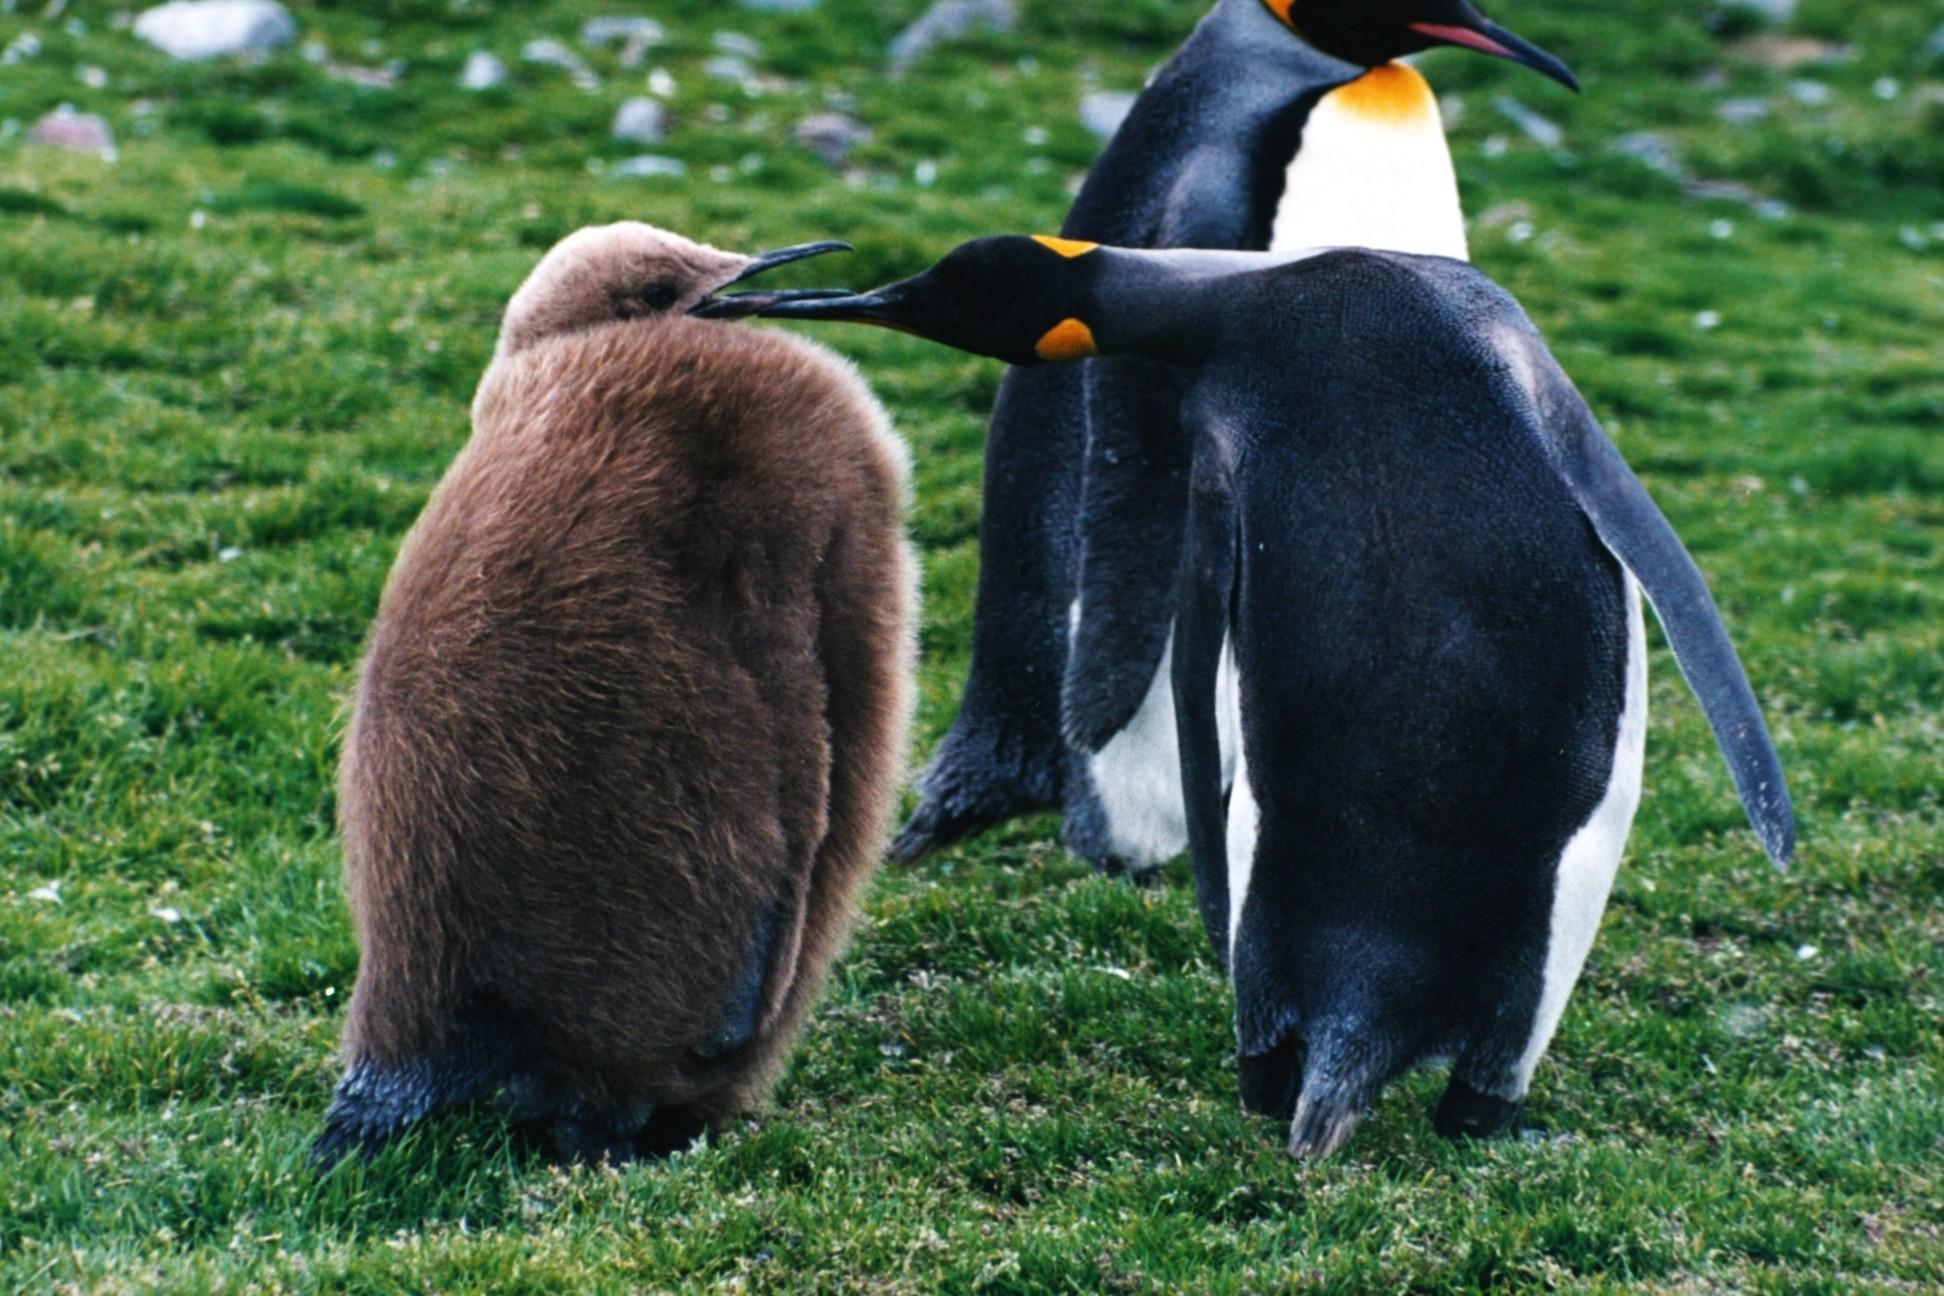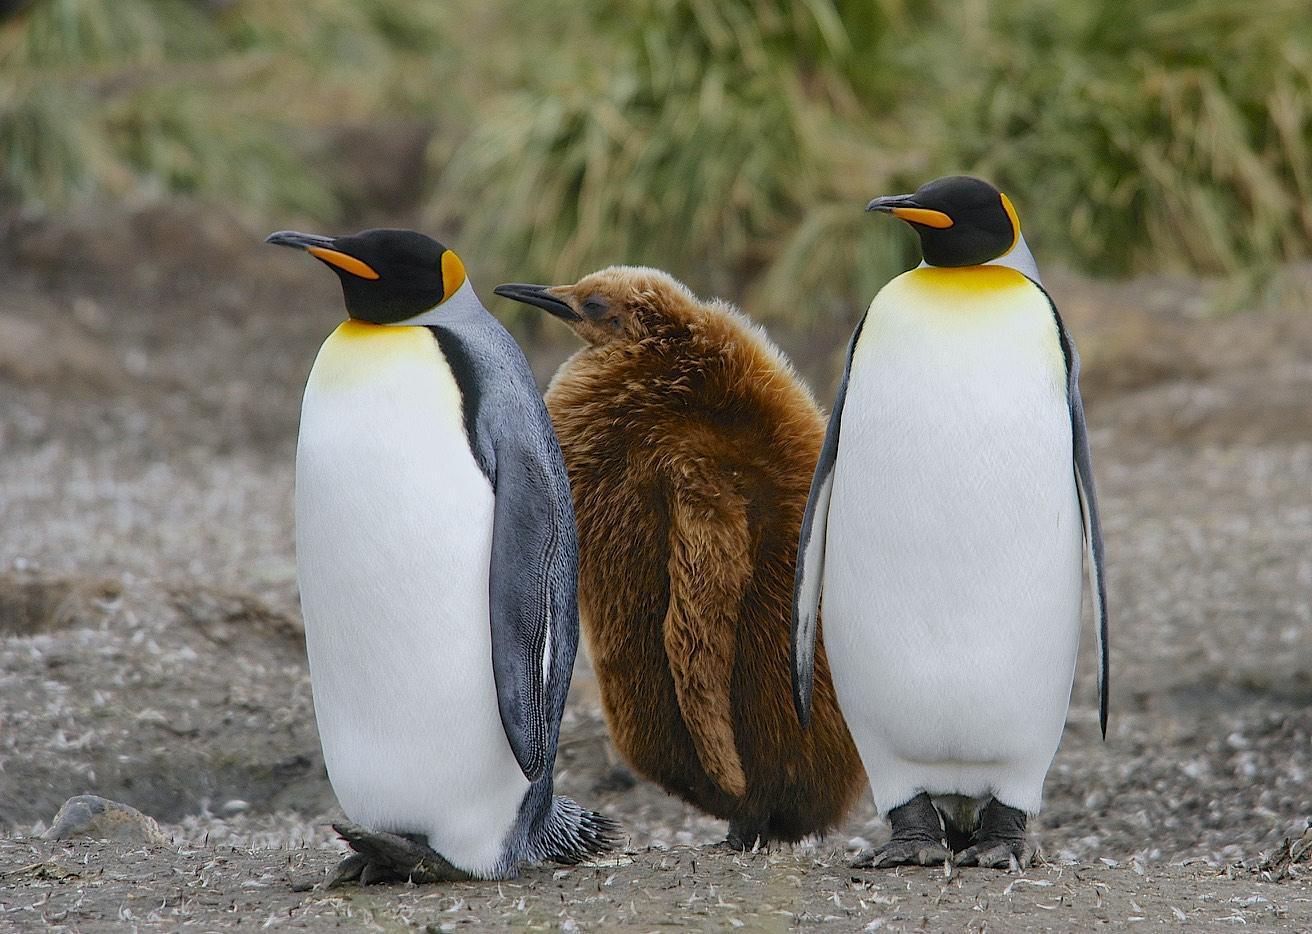The first image is the image on the left, the second image is the image on the right. Assess this claim about the two images: "There is exactly two penguins in the right image.". Correct or not? Answer yes or no. No. The first image is the image on the left, the second image is the image on the right. For the images displayed, is the sentence "There is one king penguin and one brown furry penguin in the right image." factually correct? Answer yes or no. No. 